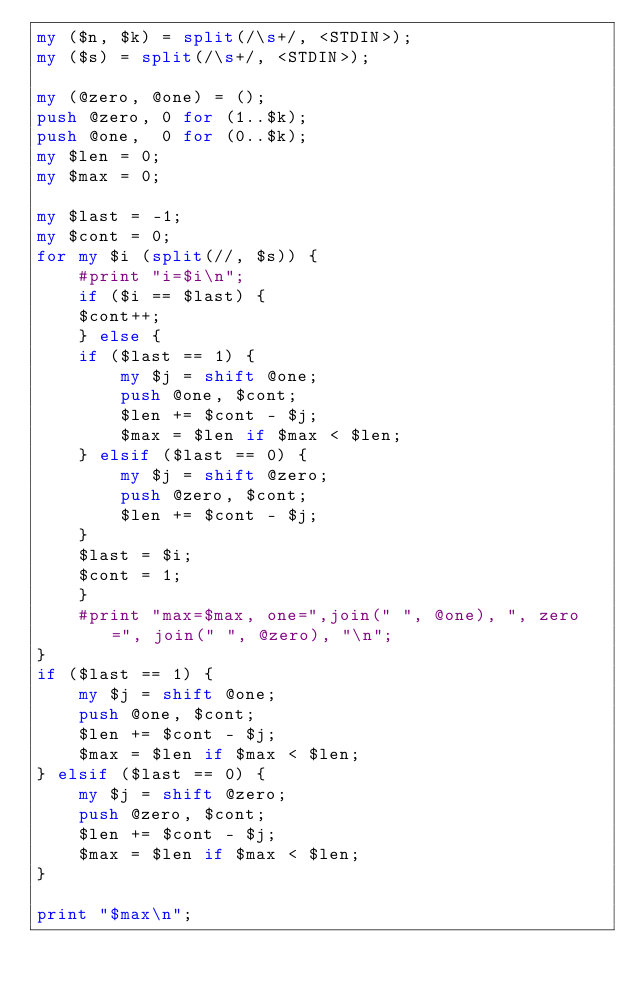<code> <loc_0><loc_0><loc_500><loc_500><_Perl_>my ($n, $k) = split(/\s+/, <STDIN>);
my ($s) = split(/\s+/, <STDIN>);

my (@zero, @one) = ();
push @zero, 0 for (1..$k);
push @one,  0 for (0..$k);
my $len = 0;
my $max = 0;

my $last = -1;
my $cont = 0;
for my $i (split(//, $s)) {
    #print "i=$i\n";
    if ($i == $last) {
	$cont++;
    } else {
	if ($last == 1) {
	    my $j = shift @one;
	    push @one, $cont;
	    $len += $cont - $j;
	    $max = $len if $max < $len;
	} elsif ($last == 0) {
	    my $j = shift @zero;
	    push @zero, $cont;
	    $len += $cont - $j;
	}
	$last = $i;
	$cont = 1;
    }
    #print "max=$max, one=",join(" ", @one), ", zero=", join(" ", @zero), "\n";
}
if ($last == 1) {
    my $j = shift @one;
    push @one, $cont;
    $len += $cont - $j;
    $max = $len if $max < $len;
} elsif ($last == 0) {
    my $j = shift @zero;
    push @zero, $cont;
    $len += $cont - $j;
    $max = $len if $max < $len;
}

print "$max\n";
</code> 